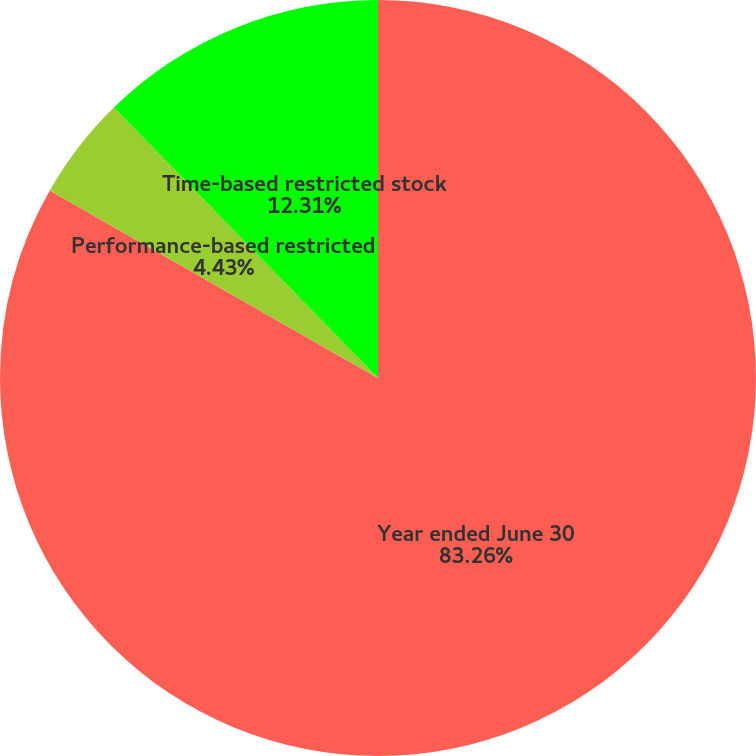Convert chart. <chart><loc_0><loc_0><loc_500><loc_500><pie_chart><fcel>Year ended June 30<fcel>Performance-based restricted<fcel>Time-based restricted stock<nl><fcel>83.25%<fcel>4.43%<fcel>12.31%<nl></chart> 